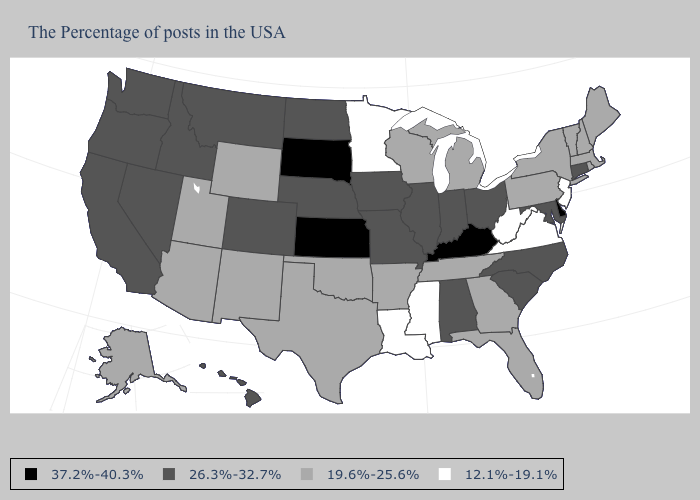Among the states that border Mississippi , which have the lowest value?
Short answer required. Louisiana. Among the states that border Delaware , does New Jersey have the highest value?
Answer briefly. No. Name the states that have a value in the range 12.1%-19.1%?
Concise answer only. New Jersey, Virginia, West Virginia, Mississippi, Louisiana, Minnesota. Name the states that have a value in the range 26.3%-32.7%?
Write a very short answer. Connecticut, Maryland, North Carolina, South Carolina, Ohio, Indiana, Alabama, Illinois, Missouri, Iowa, Nebraska, North Dakota, Colorado, Montana, Idaho, Nevada, California, Washington, Oregon, Hawaii. What is the value of Oklahoma?
Concise answer only. 19.6%-25.6%. What is the value of Mississippi?
Give a very brief answer. 12.1%-19.1%. What is the value of Kansas?
Be succinct. 37.2%-40.3%. Name the states that have a value in the range 12.1%-19.1%?
Quick response, please. New Jersey, Virginia, West Virginia, Mississippi, Louisiana, Minnesota. Does Utah have the same value as New Jersey?
Answer briefly. No. What is the highest value in the MidWest ?
Short answer required. 37.2%-40.3%. Name the states that have a value in the range 26.3%-32.7%?
Write a very short answer. Connecticut, Maryland, North Carolina, South Carolina, Ohio, Indiana, Alabama, Illinois, Missouri, Iowa, Nebraska, North Dakota, Colorado, Montana, Idaho, Nevada, California, Washington, Oregon, Hawaii. What is the lowest value in the USA?
Give a very brief answer. 12.1%-19.1%. What is the value of Washington?
Short answer required. 26.3%-32.7%. Which states have the lowest value in the USA?
Concise answer only. New Jersey, Virginia, West Virginia, Mississippi, Louisiana, Minnesota. What is the value of Georgia?
Write a very short answer. 19.6%-25.6%. 